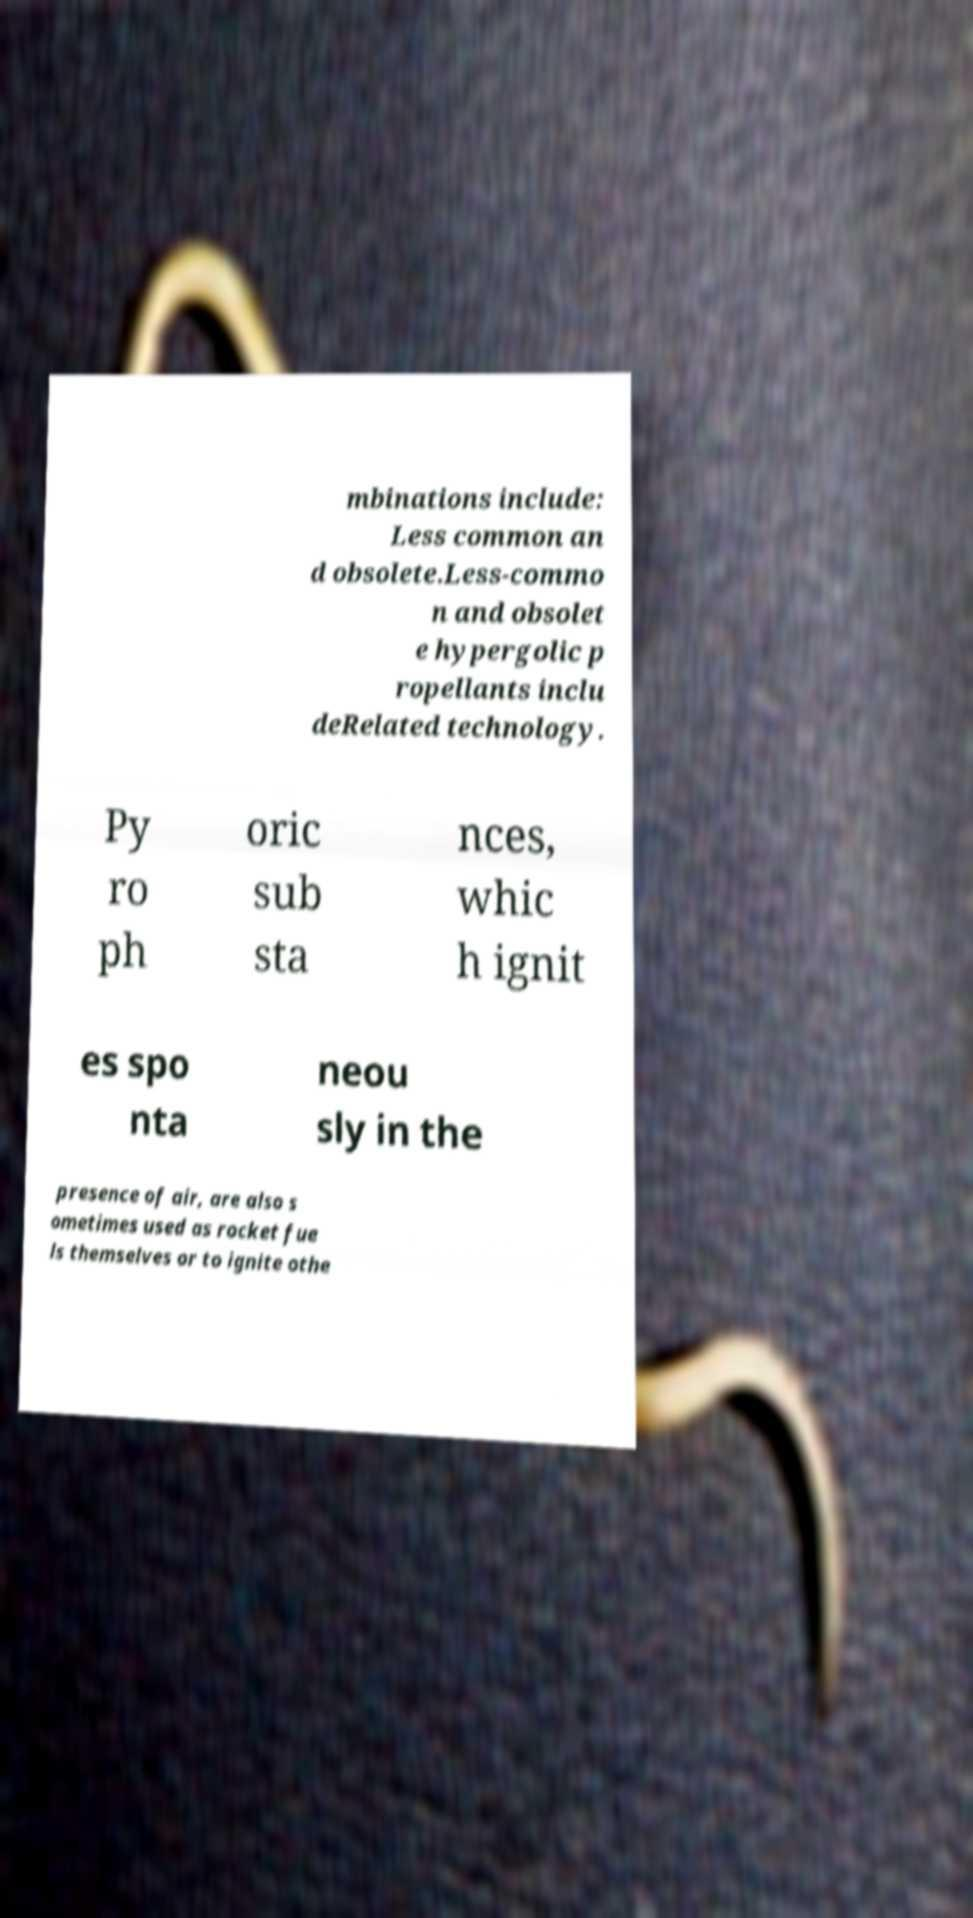I need the written content from this picture converted into text. Can you do that? mbinations include: Less common an d obsolete.Less-commo n and obsolet e hypergolic p ropellants inclu deRelated technology. Py ro ph oric sub sta nces, whic h ignit es spo nta neou sly in the presence of air, are also s ometimes used as rocket fue ls themselves or to ignite othe 